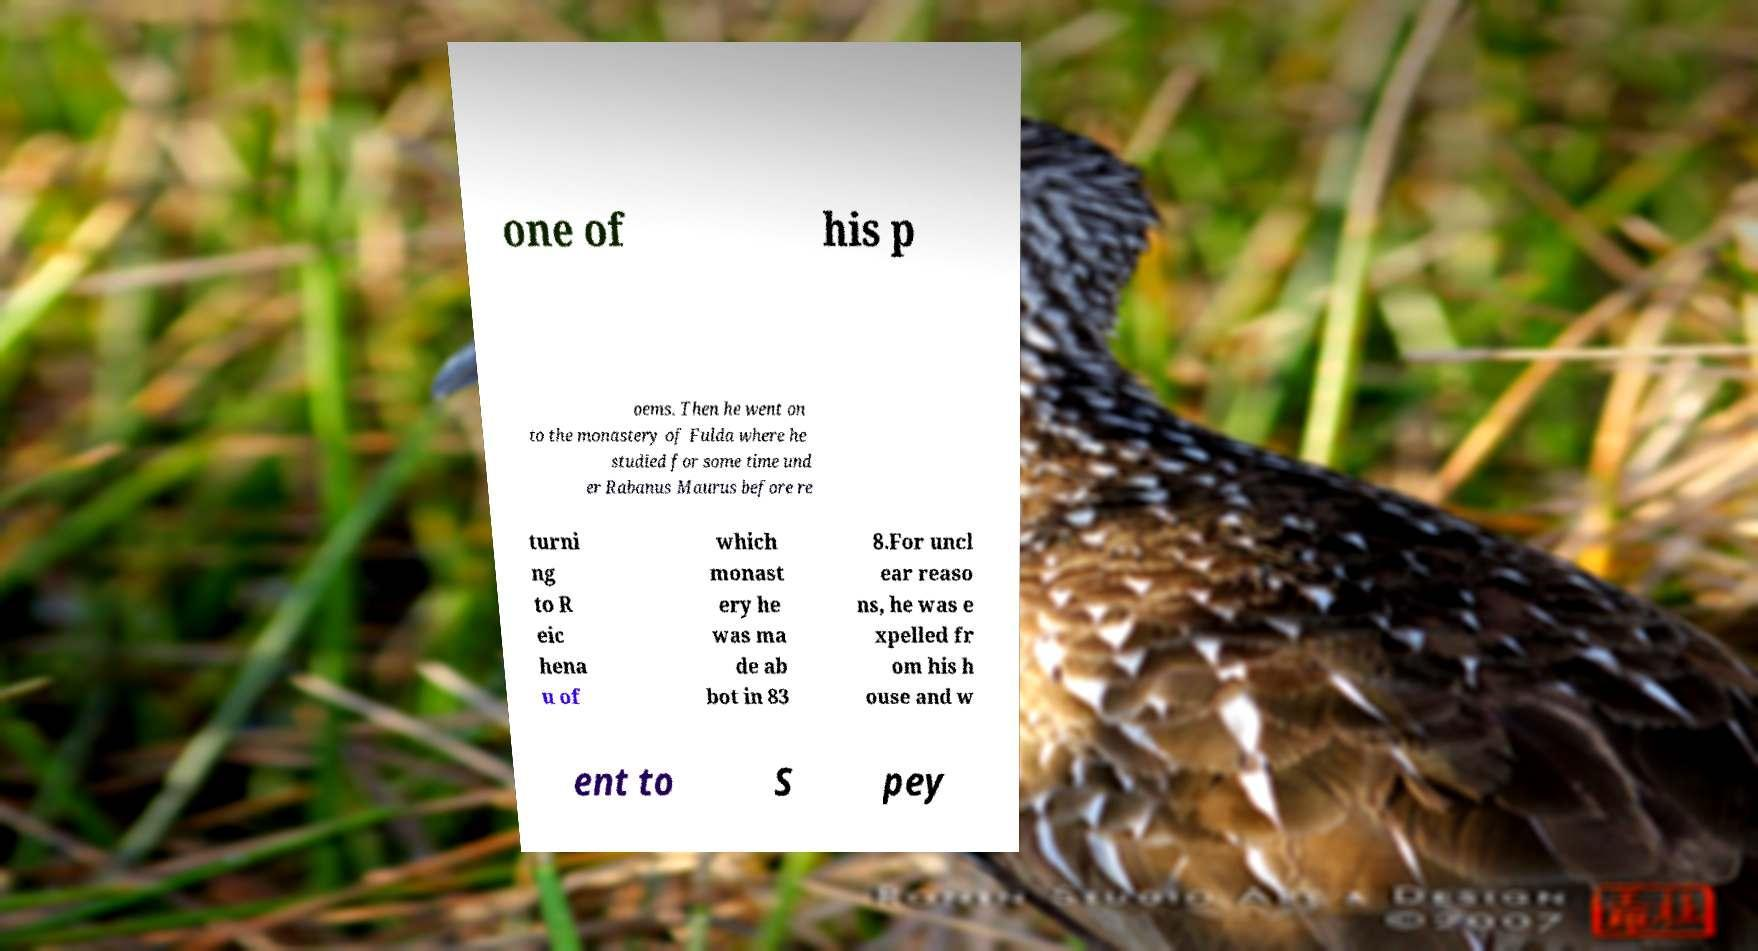Can you read and provide the text displayed in the image?This photo seems to have some interesting text. Can you extract and type it out for me? one of his p oems. Then he went on to the monastery of Fulda where he studied for some time und er Rabanus Maurus before re turni ng to R eic hena u of which monast ery he was ma de ab bot in 83 8.For uncl ear reaso ns, he was e xpelled fr om his h ouse and w ent to S pey 